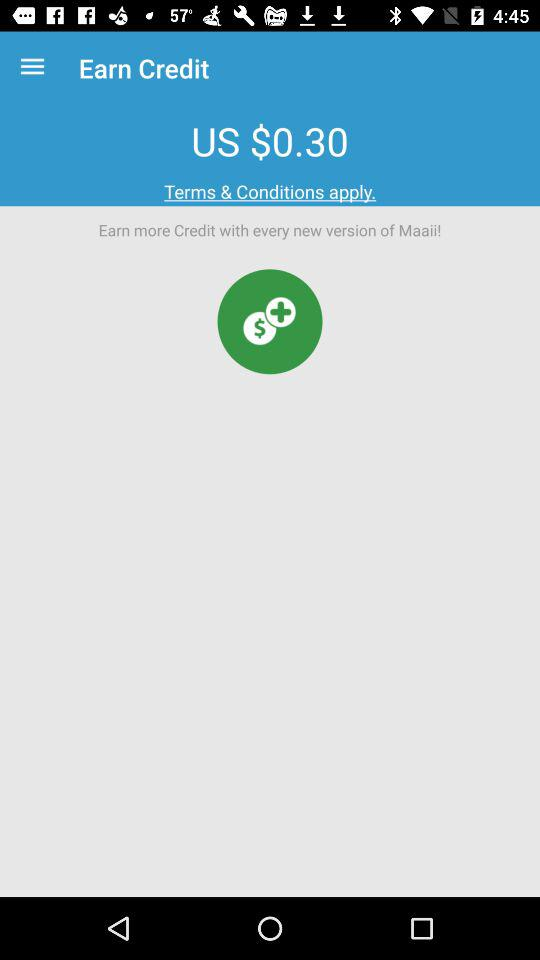What information is provided in the terms and conditions?
When the provided information is insufficient, respond with <no answer>. <no answer> 